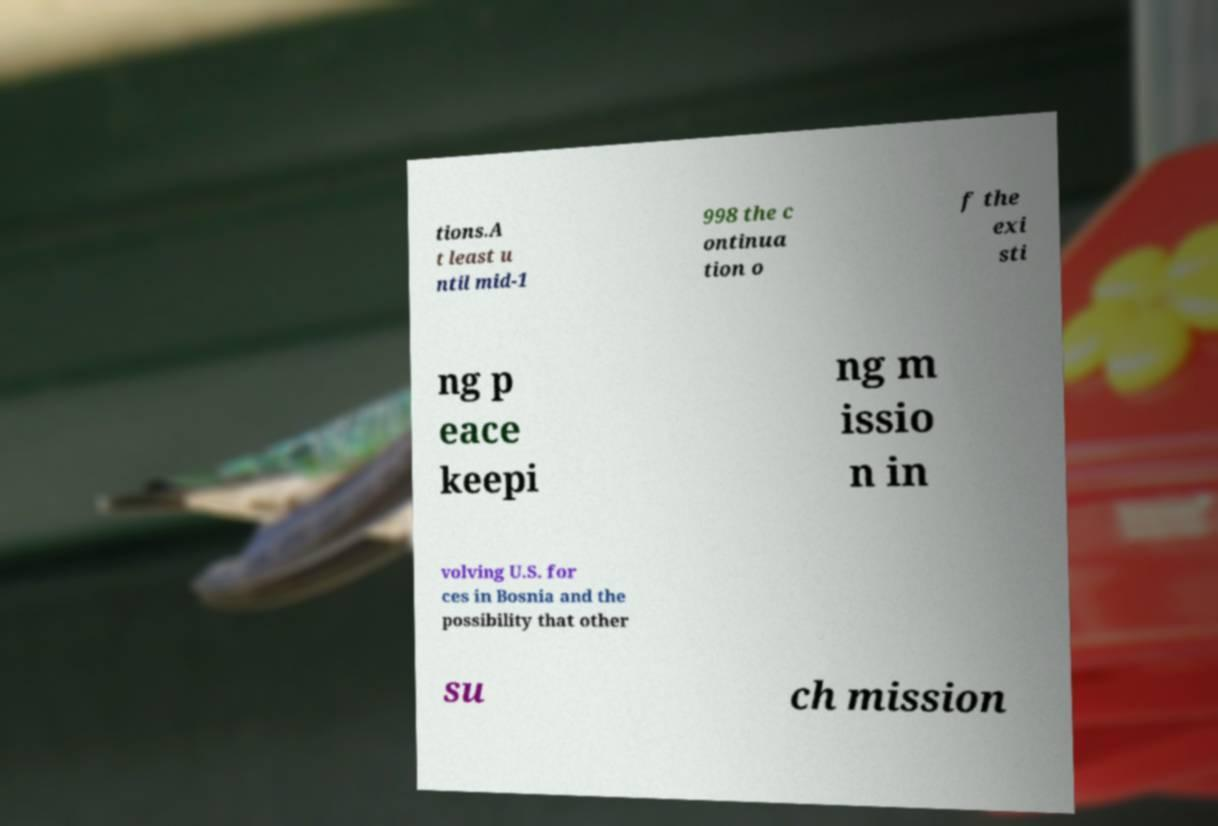For documentation purposes, I need the text within this image transcribed. Could you provide that? tions.A t least u ntil mid-1 998 the c ontinua tion o f the exi sti ng p eace keepi ng m issio n in volving U.S. for ces in Bosnia and the possibility that other su ch mission 